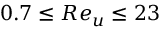<formula> <loc_0><loc_0><loc_500><loc_500>0 . 7 \leq R e _ { u } \leq 2 3</formula> 